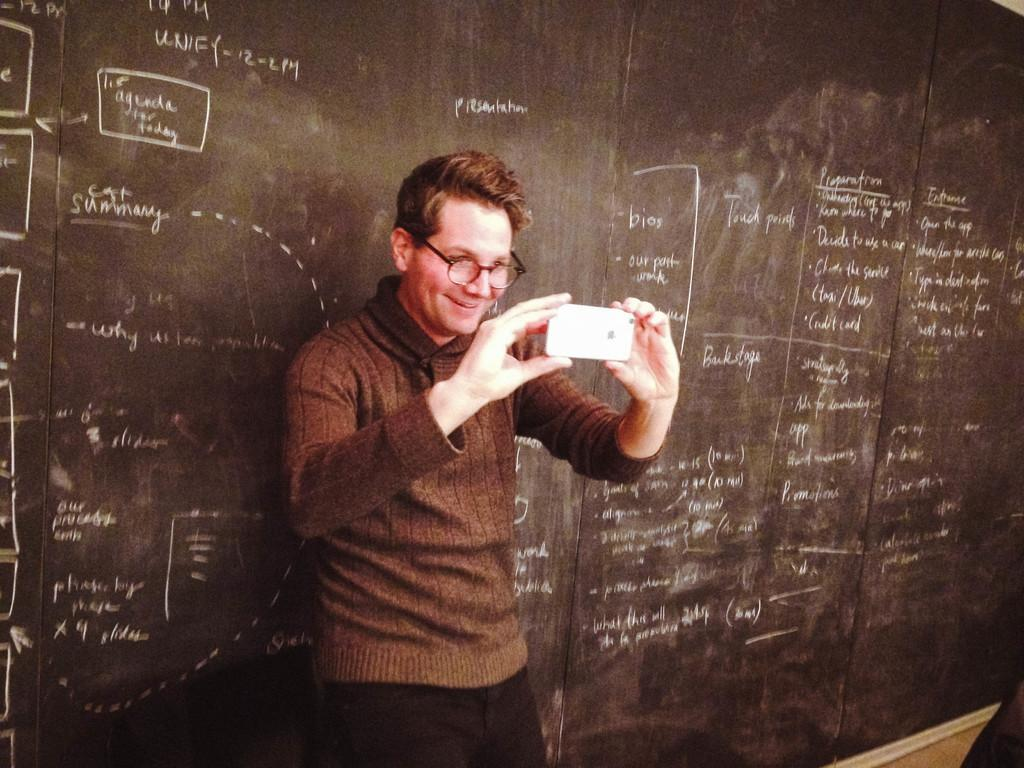Who or what is the main subject in the image? There is a person in the image. What is the person doing in the image? The person is in front of a board and holding a phone with his hands. What can be seen on the person's face? The person is wearing spectacles. What is the person wearing in the image? The person is wearing clothes. What type of clock can be seen hanging on the wall behind the person in the image? There is no clock visible in the image; it only shows a person in front of a board, holding a phone, and wearing spectacles. 